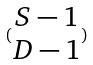Convert formula to latex. <formula><loc_0><loc_0><loc_500><loc_500>( \begin{matrix} S - 1 \\ D - 1 \end{matrix} )</formula> 